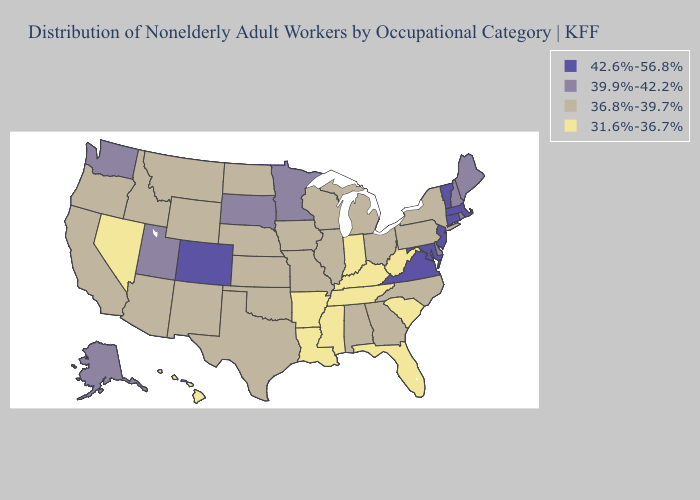Does Alabama have a lower value than Oregon?
Write a very short answer. No. Does Virginia have the same value as Mississippi?
Concise answer only. No. What is the value of Vermont?
Concise answer only. 42.6%-56.8%. What is the lowest value in states that border Washington?
Answer briefly. 36.8%-39.7%. Among the states that border Kentucky , which have the lowest value?
Answer briefly. Indiana, Tennessee, West Virginia. What is the value of West Virginia?
Concise answer only. 31.6%-36.7%. Among the states that border Massachusetts , which have the lowest value?
Write a very short answer. New York. Does the map have missing data?
Answer briefly. No. Does Indiana have the lowest value in the MidWest?
Give a very brief answer. Yes. What is the value of North Dakota?
Answer briefly. 36.8%-39.7%. Among the states that border Iowa , which have the highest value?
Keep it brief. Minnesota, South Dakota. Does the first symbol in the legend represent the smallest category?
Quick response, please. No. Does Michigan have a lower value than California?
Quick response, please. No. What is the value of Maine?
Keep it brief. 39.9%-42.2%. Does Hawaii have the highest value in the USA?
Give a very brief answer. No. 